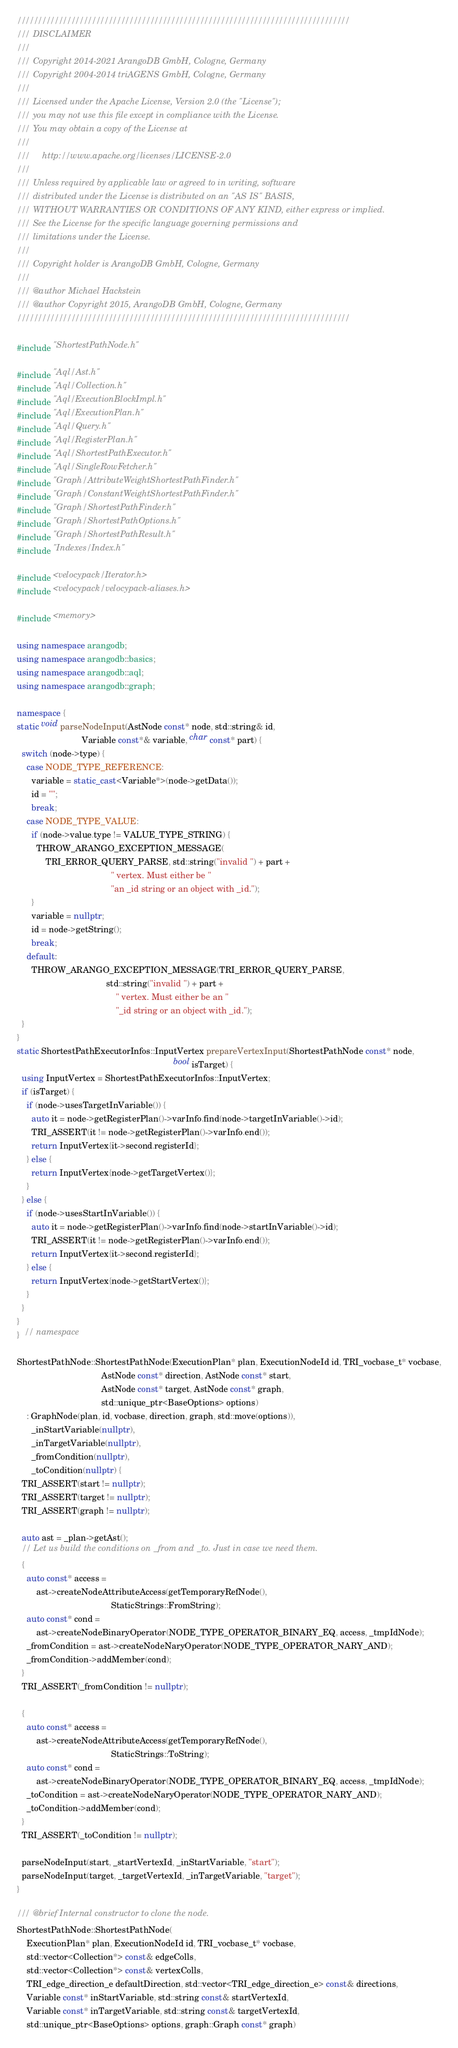Convert code to text. <code><loc_0><loc_0><loc_500><loc_500><_C++_>////////////////////////////////////////////////////////////////////////////////
/// DISCLAIMER
///
/// Copyright 2014-2021 ArangoDB GmbH, Cologne, Germany
/// Copyright 2004-2014 triAGENS GmbH, Cologne, Germany
///
/// Licensed under the Apache License, Version 2.0 (the "License");
/// you may not use this file except in compliance with the License.
/// You may obtain a copy of the License at
///
///     http://www.apache.org/licenses/LICENSE-2.0
///
/// Unless required by applicable law or agreed to in writing, software
/// distributed under the License is distributed on an "AS IS" BASIS,
/// WITHOUT WARRANTIES OR CONDITIONS OF ANY KIND, either express or implied.
/// See the License for the specific language governing permissions and
/// limitations under the License.
///
/// Copyright holder is ArangoDB GmbH, Cologne, Germany
///
/// @author Michael Hackstein
/// @author Copyright 2015, ArangoDB GmbH, Cologne, Germany
////////////////////////////////////////////////////////////////////////////////

#include "ShortestPathNode.h"

#include "Aql/Ast.h"
#include "Aql/Collection.h"
#include "Aql/ExecutionBlockImpl.h"
#include "Aql/ExecutionPlan.h"
#include "Aql/Query.h"
#include "Aql/RegisterPlan.h"
#include "Aql/ShortestPathExecutor.h"
#include "Aql/SingleRowFetcher.h"
#include "Graph/AttributeWeightShortestPathFinder.h"
#include "Graph/ConstantWeightShortestPathFinder.h"
#include "Graph/ShortestPathFinder.h"
#include "Graph/ShortestPathOptions.h"
#include "Graph/ShortestPathResult.h"
#include "Indexes/Index.h"

#include <velocypack/Iterator.h>
#include <velocypack/velocypack-aliases.h>

#include <memory>

using namespace arangodb;
using namespace arangodb::basics;
using namespace arangodb::aql;
using namespace arangodb::graph;

namespace {
static void parseNodeInput(AstNode const* node, std::string& id,
                           Variable const*& variable, char const* part) {
  switch (node->type) {
    case NODE_TYPE_REFERENCE:
      variable = static_cast<Variable*>(node->getData());
      id = "";
      break;
    case NODE_TYPE_VALUE:
      if (node->value.type != VALUE_TYPE_STRING) {
        THROW_ARANGO_EXCEPTION_MESSAGE(
            TRI_ERROR_QUERY_PARSE, std::string("invalid ") + part +
                                       " vertex. Must either be "
                                       "an _id string or an object with _id.");
      }
      variable = nullptr;
      id = node->getString();
      break;
    default:
      THROW_ARANGO_EXCEPTION_MESSAGE(TRI_ERROR_QUERY_PARSE,
                                     std::string("invalid ") + part +
                                         " vertex. Must either be an "
                                         "_id string or an object with _id.");
  }
}
static ShortestPathExecutorInfos::InputVertex prepareVertexInput(ShortestPathNode const* node,
                                                                 bool isTarget) {
  using InputVertex = ShortestPathExecutorInfos::InputVertex;
  if (isTarget) {
    if (node->usesTargetInVariable()) {
      auto it = node->getRegisterPlan()->varInfo.find(node->targetInVariable()->id);
      TRI_ASSERT(it != node->getRegisterPlan()->varInfo.end());
      return InputVertex{it->second.registerId};
    } else {
      return InputVertex{node->getTargetVertex()};
    }
  } else {
    if (node->usesStartInVariable()) {
      auto it = node->getRegisterPlan()->varInfo.find(node->startInVariable()->id);
      TRI_ASSERT(it != node->getRegisterPlan()->varInfo.end());
      return InputVertex{it->second.registerId};
    } else {
      return InputVertex{node->getStartVertex()};
    }
  }
}
}  // namespace

ShortestPathNode::ShortestPathNode(ExecutionPlan* plan, ExecutionNodeId id, TRI_vocbase_t* vocbase,
                                   AstNode const* direction, AstNode const* start,
                                   AstNode const* target, AstNode const* graph,
                                   std::unique_ptr<BaseOptions> options)
    : GraphNode(plan, id, vocbase, direction, graph, std::move(options)),
      _inStartVariable(nullptr),
      _inTargetVariable(nullptr),
      _fromCondition(nullptr),
      _toCondition(nullptr) {
  TRI_ASSERT(start != nullptr);
  TRI_ASSERT(target != nullptr);
  TRI_ASSERT(graph != nullptr);

  auto ast = _plan->getAst();
  // Let us build the conditions on _from and _to. Just in case we need them.
  {
    auto const* access =
        ast->createNodeAttributeAccess(getTemporaryRefNode(),
                                       StaticStrings::FromString);
    auto const* cond =
        ast->createNodeBinaryOperator(NODE_TYPE_OPERATOR_BINARY_EQ, access, _tmpIdNode);
    _fromCondition = ast->createNodeNaryOperator(NODE_TYPE_OPERATOR_NARY_AND);
    _fromCondition->addMember(cond);
  }
  TRI_ASSERT(_fromCondition != nullptr);

  {
    auto const* access =
        ast->createNodeAttributeAccess(getTemporaryRefNode(),
                                       StaticStrings::ToString);
    auto const* cond =
        ast->createNodeBinaryOperator(NODE_TYPE_OPERATOR_BINARY_EQ, access, _tmpIdNode);
    _toCondition = ast->createNodeNaryOperator(NODE_TYPE_OPERATOR_NARY_AND);
    _toCondition->addMember(cond);
  }
  TRI_ASSERT(_toCondition != nullptr);

  parseNodeInput(start, _startVertexId, _inStartVariable, "start");
  parseNodeInput(target, _targetVertexId, _inTargetVariable, "target");
}

/// @brief Internal constructor to clone the node.
ShortestPathNode::ShortestPathNode(
    ExecutionPlan* plan, ExecutionNodeId id, TRI_vocbase_t* vocbase,
    std::vector<Collection*> const& edgeColls,
    std::vector<Collection*> const& vertexColls,
    TRI_edge_direction_e defaultDirection, std::vector<TRI_edge_direction_e> const& directions,
    Variable const* inStartVariable, std::string const& startVertexId,
    Variable const* inTargetVariable, std::string const& targetVertexId,
    std::unique_ptr<BaseOptions> options, graph::Graph const* graph)</code> 